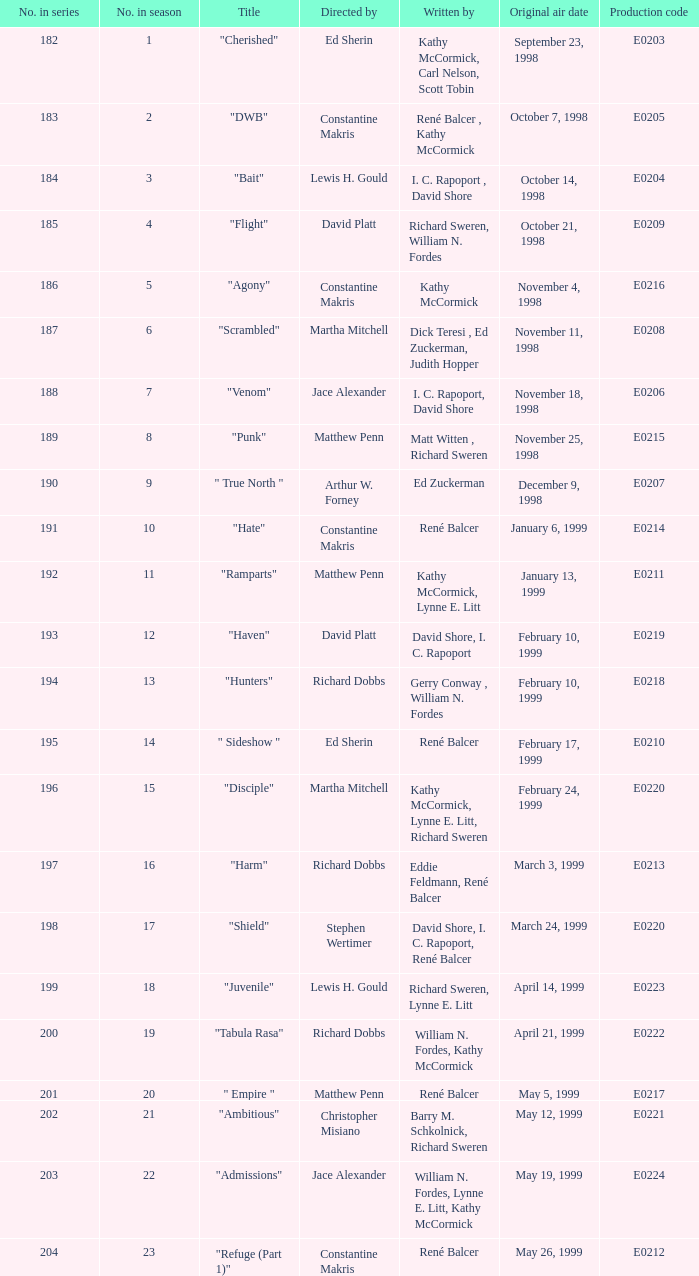The episode with original air date January 13, 1999 is written by who? Kathy McCormick, Lynne E. Litt. 